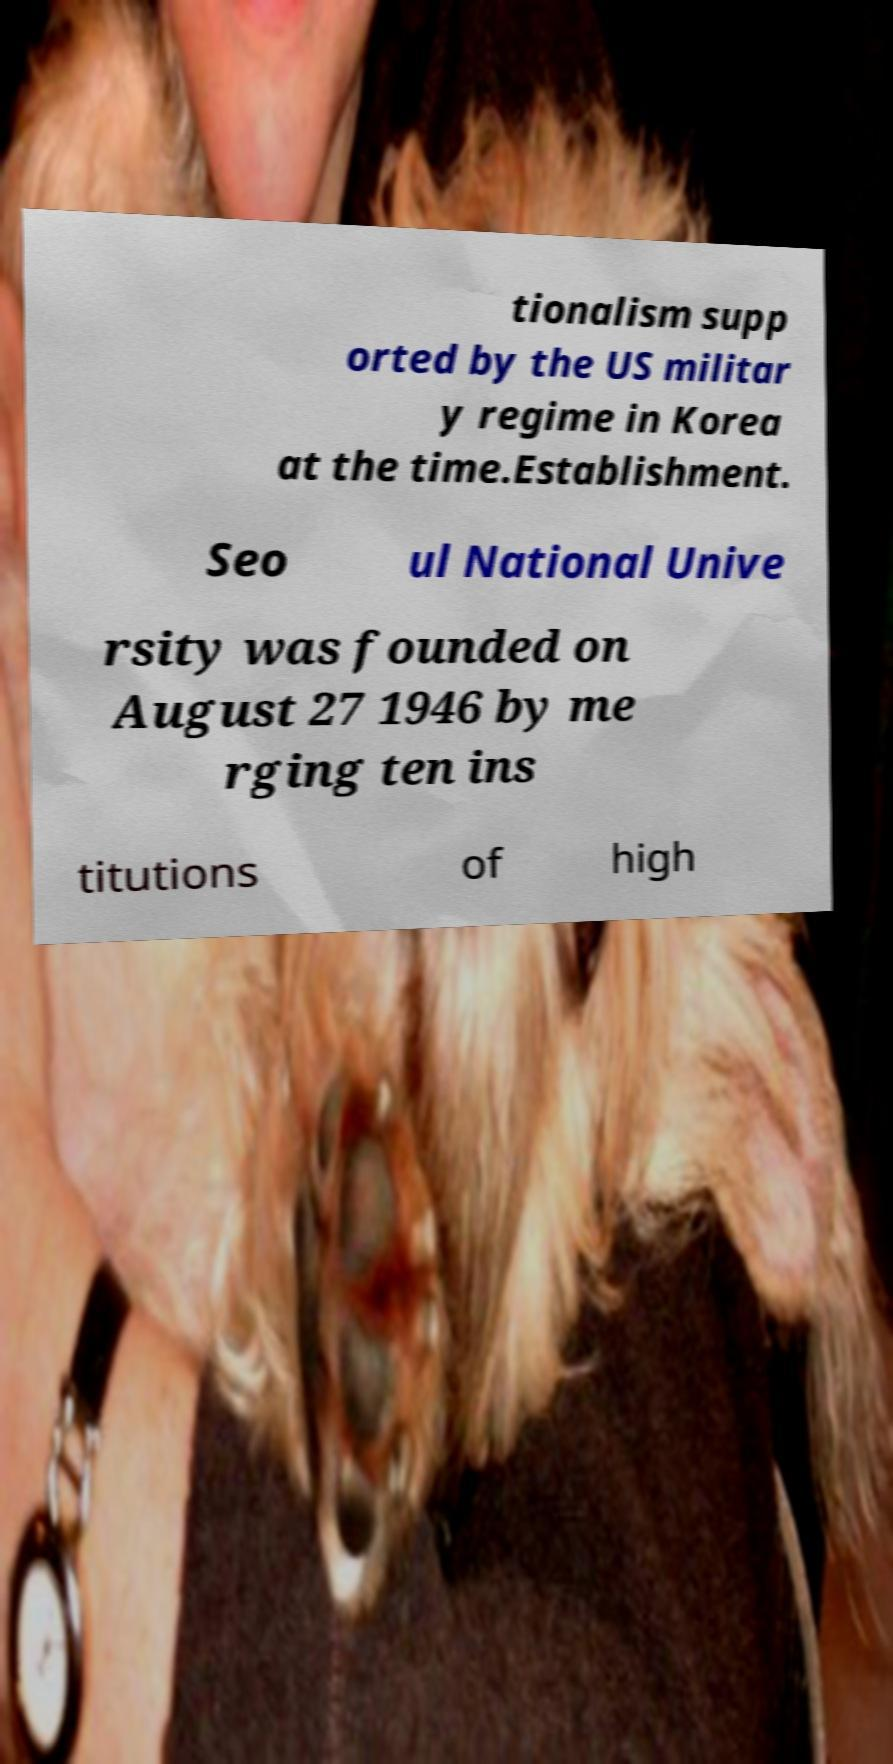Could you extract and type out the text from this image? tionalism supp orted by the US militar y regime in Korea at the time.Establishment. Seo ul National Unive rsity was founded on August 27 1946 by me rging ten ins titutions of high 